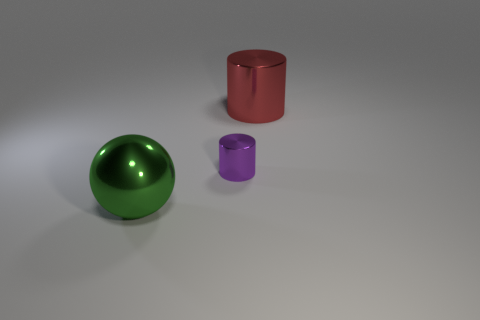Add 3 metal balls. How many objects exist? 6 Subtract all spheres. How many objects are left? 2 Subtract 0 cyan balls. How many objects are left? 3 Subtract all tiny red spheres. Subtract all purple metallic cylinders. How many objects are left? 2 Add 2 tiny cylinders. How many tiny cylinders are left? 3 Add 3 red cylinders. How many red cylinders exist? 4 